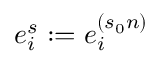<formula> <loc_0><loc_0><loc_500><loc_500>e _ { i } ^ { s } \colon = e _ { i } ^ { ( s _ { 0 } n ) }</formula> 